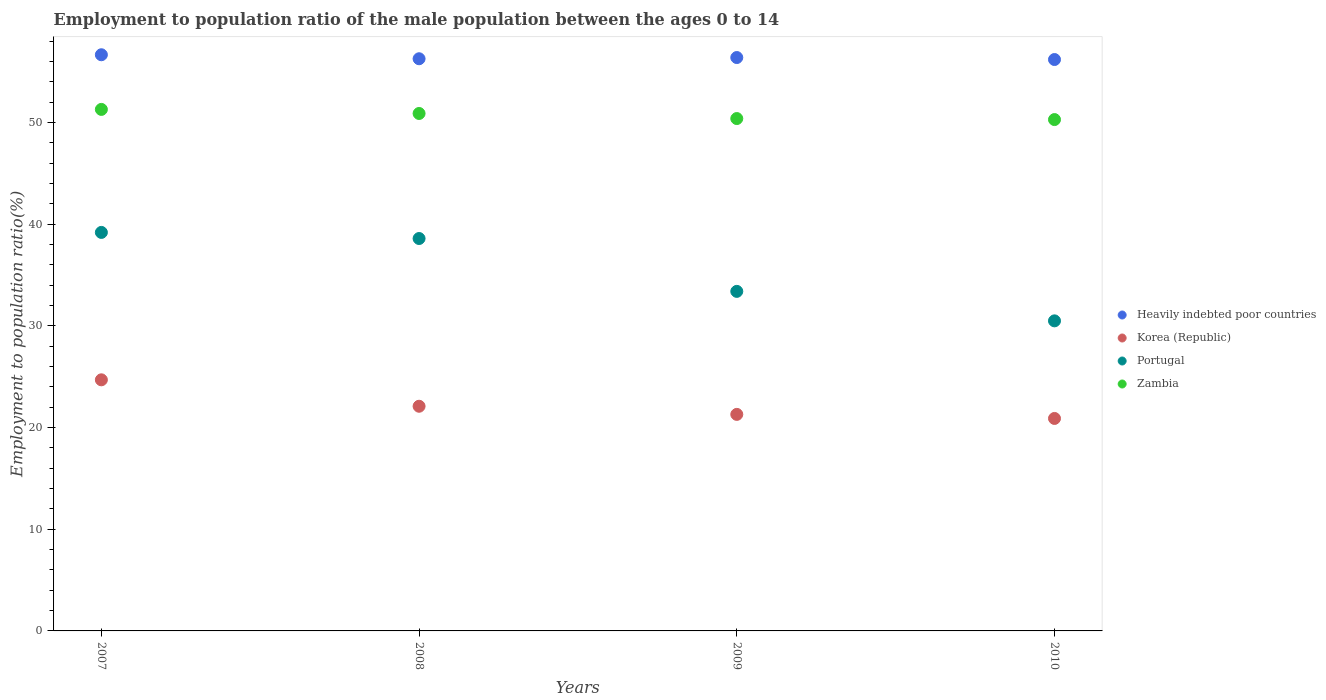What is the employment to population ratio in Korea (Republic) in 2010?
Offer a terse response. 20.9. Across all years, what is the maximum employment to population ratio in Portugal?
Keep it short and to the point. 39.2. Across all years, what is the minimum employment to population ratio in Korea (Republic)?
Your answer should be compact. 20.9. In which year was the employment to population ratio in Heavily indebted poor countries maximum?
Give a very brief answer. 2007. What is the total employment to population ratio in Korea (Republic) in the graph?
Keep it short and to the point. 89. What is the difference between the employment to population ratio in Zambia in 2007 and that in 2009?
Give a very brief answer. 0.9. What is the difference between the employment to population ratio in Korea (Republic) in 2008 and the employment to population ratio in Portugal in 2009?
Offer a terse response. -11.3. What is the average employment to population ratio in Korea (Republic) per year?
Keep it short and to the point. 22.25. In the year 2010, what is the difference between the employment to population ratio in Heavily indebted poor countries and employment to population ratio in Korea (Republic)?
Your answer should be very brief. 35.31. In how many years, is the employment to population ratio in Zambia greater than 8 %?
Give a very brief answer. 4. What is the ratio of the employment to population ratio in Zambia in 2007 to that in 2008?
Your answer should be compact. 1.01. Is the difference between the employment to population ratio in Heavily indebted poor countries in 2007 and 2010 greater than the difference between the employment to population ratio in Korea (Republic) in 2007 and 2010?
Your response must be concise. No. What is the difference between the highest and the second highest employment to population ratio in Heavily indebted poor countries?
Your response must be concise. 0.27. What is the difference between the highest and the lowest employment to population ratio in Portugal?
Make the answer very short. 8.7. In how many years, is the employment to population ratio in Korea (Republic) greater than the average employment to population ratio in Korea (Republic) taken over all years?
Your answer should be very brief. 1. Is the sum of the employment to population ratio in Zambia in 2007 and 2008 greater than the maximum employment to population ratio in Portugal across all years?
Provide a short and direct response. Yes. Is it the case that in every year, the sum of the employment to population ratio in Heavily indebted poor countries and employment to population ratio in Zambia  is greater than the sum of employment to population ratio in Portugal and employment to population ratio in Korea (Republic)?
Ensure brevity in your answer.  Yes. Does the employment to population ratio in Korea (Republic) monotonically increase over the years?
Your response must be concise. No. Is the employment to population ratio in Heavily indebted poor countries strictly less than the employment to population ratio in Portugal over the years?
Keep it short and to the point. No. How many dotlines are there?
Your answer should be very brief. 4. What is the difference between two consecutive major ticks on the Y-axis?
Give a very brief answer. 10. Are the values on the major ticks of Y-axis written in scientific E-notation?
Your answer should be very brief. No. Does the graph contain any zero values?
Your answer should be very brief. No. Does the graph contain grids?
Your answer should be very brief. No. Where does the legend appear in the graph?
Offer a terse response. Center right. How many legend labels are there?
Make the answer very short. 4. How are the legend labels stacked?
Provide a succinct answer. Vertical. What is the title of the graph?
Your response must be concise. Employment to population ratio of the male population between the ages 0 to 14. Does "St. Vincent and the Grenadines" appear as one of the legend labels in the graph?
Make the answer very short. No. What is the label or title of the X-axis?
Your answer should be compact. Years. What is the Employment to population ratio(%) of Heavily indebted poor countries in 2007?
Your response must be concise. 56.68. What is the Employment to population ratio(%) in Korea (Republic) in 2007?
Ensure brevity in your answer.  24.7. What is the Employment to population ratio(%) in Portugal in 2007?
Keep it short and to the point. 39.2. What is the Employment to population ratio(%) of Zambia in 2007?
Your response must be concise. 51.3. What is the Employment to population ratio(%) of Heavily indebted poor countries in 2008?
Give a very brief answer. 56.28. What is the Employment to population ratio(%) in Korea (Republic) in 2008?
Keep it short and to the point. 22.1. What is the Employment to population ratio(%) in Portugal in 2008?
Ensure brevity in your answer.  38.6. What is the Employment to population ratio(%) of Zambia in 2008?
Ensure brevity in your answer.  50.9. What is the Employment to population ratio(%) of Heavily indebted poor countries in 2009?
Keep it short and to the point. 56.4. What is the Employment to population ratio(%) of Korea (Republic) in 2009?
Provide a succinct answer. 21.3. What is the Employment to population ratio(%) of Portugal in 2009?
Your response must be concise. 33.4. What is the Employment to population ratio(%) of Zambia in 2009?
Provide a succinct answer. 50.4. What is the Employment to population ratio(%) of Heavily indebted poor countries in 2010?
Provide a succinct answer. 56.21. What is the Employment to population ratio(%) in Korea (Republic) in 2010?
Offer a terse response. 20.9. What is the Employment to population ratio(%) in Portugal in 2010?
Provide a short and direct response. 30.5. What is the Employment to population ratio(%) of Zambia in 2010?
Ensure brevity in your answer.  50.3. Across all years, what is the maximum Employment to population ratio(%) in Heavily indebted poor countries?
Keep it short and to the point. 56.68. Across all years, what is the maximum Employment to population ratio(%) in Korea (Republic)?
Provide a short and direct response. 24.7. Across all years, what is the maximum Employment to population ratio(%) of Portugal?
Your answer should be compact. 39.2. Across all years, what is the maximum Employment to population ratio(%) of Zambia?
Your response must be concise. 51.3. Across all years, what is the minimum Employment to population ratio(%) of Heavily indebted poor countries?
Offer a terse response. 56.21. Across all years, what is the minimum Employment to population ratio(%) in Korea (Republic)?
Keep it short and to the point. 20.9. Across all years, what is the minimum Employment to population ratio(%) of Portugal?
Provide a succinct answer. 30.5. Across all years, what is the minimum Employment to population ratio(%) in Zambia?
Offer a very short reply. 50.3. What is the total Employment to population ratio(%) in Heavily indebted poor countries in the graph?
Keep it short and to the point. 225.57. What is the total Employment to population ratio(%) in Korea (Republic) in the graph?
Your answer should be compact. 89. What is the total Employment to population ratio(%) in Portugal in the graph?
Provide a succinct answer. 141.7. What is the total Employment to population ratio(%) of Zambia in the graph?
Offer a very short reply. 202.9. What is the difference between the Employment to population ratio(%) of Heavily indebted poor countries in 2007 and that in 2008?
Provide a short and direct response. 0.39. What is the difference between the Employment to population ratio(%) of Korea (Republic) in 2007 and that in 2008?
Your answer should be compact. 2.6. What is the difference between the Employment to population ratio(%) of Portugal in 2007 and that in 2008?
Offer a terse response. 0.6. What is the difference between the Employment to population ratio(%) in Heavily indebted poor countries in 2007 and that in 2009?
Offer a very short reply. 0.27. What is the difference between the Employment to population ratio(%) in Korea (Republic) in 2007 and that in 2009?
Make the answer very short. 3.4. What is the difference between the Employment to population ratio(%) of Portugal in 2007 and that in 2009?
Your answer should be very brief. 5.8. What is the difference between the Employment to population ratio(%) in Heavily indebted poor countries in 2007 and that in 2010?
Keep it short and to the point. 0.47. What is the difference between the Employment to population ratio(%) in Zambia in 2007 and that in 2010?
Your answer should be compact. 1. What is the difference between the Employment to population ratio(%) of Heavily indebted poor countries in 2008 and that in 2009?
Ensure brevity in your answer.  -0.12. What is the difference between the Employment to population ratio(%) in Korea (Republic) in 2008 and that in 2009?
Offer a very short reply. 0.8. What is the difference between the Employment to population ratio(%) of Portugal in 2008 and that in 2009?
Offer a very short reply. 5.2. What is the difference between the Employment to population ratio(%) of Heavily indebted poor countries in 2008 and that in 2010?
Offer a terse response. 0.08. What is the difference between the Employment to population ratio(%) in Portugal in 2008 and that in 2010?
Ensure brevity in your answer.  8.1. What is the difference between the Employment to population ratio(%) of Zambia in 2008 and that in 2010?
Keep it short and to the point. 0.6. What is the difference between the Employment to population ratio(%) of Heavily indebted poor countries in 2009 and that in 2010?
Give a very brief answer. 0.2. What is the difference between the Employment to population ratio(%) of Heavily indebted poor countries in 2007 and the Employment to population ratio(%) of Korea (Republic) in 2008?
Your response must be concise. 34.58. What is the difference between the Employment to population ratio(%) of Heavily indebted poor countries in 2007 and the Employment to population ratio(%) of Portugal in 2008?
Keep it short and to the point. 18.08. What is the difference between the Employment to population ratio(%) of Heavily indebted poor countries in 2007 and the Employment to population ratio(%) of Zambia in 2008?
Ensure brevity in your answer.  5.78. What is the difference between the Employment to population ratio(%) in Korea (Republic) in 2007 and the Employment to population ratio(%) in Portugal in 2008?
Ensure brevity in your answer.  -13.9. What is the difference between the Employment to population ratio(%) of Korea (Republic) in 2007 and the Employment to population ratio(%) of Zambia in 2008?
Your response must be concise. -26.2. What is the difference between the Employment to population ratio(%) of Heavily indebted poor countries in 2007 and the Employment to population ratio(%) of Korea (Republic) in 2009?
Ensure brevity in your answer.  35.38. What is the difference between the Employment to population ratio(%) in Heavily indebted poor countries in 2007 and the Employment to population ratio(%) in Portugal in 2009?
Provide a short and direct response. 23.28. What is the difference between the Employment to population ratio(%) in Heavily indebted poor countries in 2007 and the Employment to population ratio(%) in Zambia in 2009?
Make the answer very short. 6.28. What is the difference between the Employment to population ratio(%) of Korea (Republic) in 2007 and the Employment to population ratio(%) of Zambia in 2009?
Provide a short and direct response. -25.7. What is the difference between the Employment to population ratio(%) of Portugal in 2007 and the Employment to population ratio(%) of Zambia in 2009?
Make the answer very short. -11.2. What is the difference between the Employment to population ratio(%) of Heavily indebted poor countries in 2007 and the Employment to population ratio(%) of Korea (Republic) in 2010?
Your answer should be compact. 35.78. What is the difference between the Employment to population ratio(%) in Heavily indebted poor countries in 2007 and the Employment to population ratio(%) in Portugal in 2010?
Provide a succinct answer. 26.18. What is the difference between the Employment to population ratio(%) of Heavily indebted poor countries in 2007 and the Employment to population ratio(%) of Zambia in 2010?
Offer a very short reply. 6.38. What is the difference between the Employment to population ratio(%) in Korea (Republic) in 2007 and the Employment to population ratio(%) in Zambia in 2010?
Your response must be concise. -25.6. What is the difference between the Employment to population ratio(%) of Portugal in 2007 and the Employment to population ratio(%) of Zambia in 2010?
Provide a succinct answer. -11.1. What is the difference between the Employment to population ratio(%) of Heavily indebted poor countries in 2008 and the Employment to population ratio(%) of Korea (Republic) in 2009?
Your answer should be compact. 34.98. What is the difference between the Employment to population ratio(%) of Heavily indebted poor countries in 2008 and the Employment to population ratio(%) of Portugal in 2009?
Your answer should be very brief. 22.88. What is the difference between the Employment to population ratio(%) in Heavily indebted poor countries in 2008 and the Employment to population ratio(%) in Zambia in 2009?
Provide a succinct answer. 5.88. What is the difference between the Employment to population ratio(%) in Korea (Republic) in 2008 and the Employment to population ratio(%) in Zambia in 2009?
Keep it short and to the point. -28.3. What is the difference between the Employment to population ratio(%) in Portugal in 2008 and the Employment to population ratio(%) in Zambia in 2009?
Your response must be concise. -11.8. What is the difference between the Employment to population ratio(%) in Heavily indebted poor countries in 2008 and the Employment to population ratio(%) in Korea (Republic) in 2010?
Provide a succinct answer. 35.38. What is the difference between the Employment to population ratio(%) of Heavily indebted poor countries in 2008 and the Employment to population ratio(%) of Portugal in 2010?
Make the answer very short. 25.78. What is the difference between the Employment to population ratio(%) of Heavily indebted poor countries in 2008 and the Employment to population ratio(%) of Zambia in 2010?
Offer a terse response. 5.98. What is the difference between the Employment to population ratio(%) of Korea (Republic) in 2008 and the Employment to population ratio(%) of Portugal in 2010?
Your answer should be compact. -8.4. What is the difference between the Employment to population ratio(%) in Korea (Republic) in 2008 and the Employment to population ratio(%) in Zambia in 2010?
Offer a terse response. -28.2. What is the difference between the Employment to population ratio(%) of Heavily indebted poor countries in 2009 and the Employment to population ratio(%) of Korea (Republic) in 2010?
Your answer should be very brief. 35.5. What is the difference between the Employment to population ratio(%) of Heavily indebted poor countries in 2009 and the Employment to population ratio(%) of Portugal in 2010?
Keep it short and to the point. 25.9. What is the difference between the Employment to population ratio(%) in Heavily indebted poor countries in 2009 and the Employment to population ratio(%) in Zambia in 2010?
Provide a short and direct response. 6.1. What is the difference between the Employment to population ratio(%) in Korea (Republic) in 2009 and the Employment to population ratio(%) in Portugal in 2010?
Give a very brief answer. -9.2. What is the difference between the Employment to population ratio(%) in Portugal in 2009 and the Employment to population ratio(%) in Zambia in 2010?
Offer a very short reply. -16.9. What is the average Employment to population ratio(%) of Heavily indebted poor countries per year?
Your response must be concise. 56.39. What is the average Employment to population ratio(%) in Korea (Republic) per year?
Your answer should be very brief. 22.25. What is the average Employment to population ratio(%) of Portugal per year?
Your response must be concise. 35.42. What is the average Employment to population ratio(%) of Zambia per year?
Keep it short and to the point. 50.73. In the year 2007, what is the difference between the Employment to population ratio(%) in Heavily indebted poor countries and Employment to population ratio(%) in Korea (Republic)?
Offer a terse response. 31.98. In the year 2007, what is the difference between the Employment to population ratio(%) in Heavily indebted poor countries and Employment to population ratio(%) in Portugal?
Give a very brief answer. 17.48. In the year 2007, what is the difference between the Employment to population ratio(%) in Heavily indebted poor countries and Employment to population ratio(%) in Zambia?
Give a very brief answer. 5.38. In the year 2007, what is the difference between the Employment to population ratio(%) of Korea (Republic) and Employment to population ratio(%) of Portugal?
Provide a short and direct response. -14.5. In the year 2007, what is the difference between the Employment to population ratio(%) in Korea (Republic) and Employment to population ratio(%) in Zambia?
Your answer should be very brief. -26.6. In the year 2008, what is the difference between the Employment to population ratio(%) in Heavily indebted poor countries and Employment to population ratio(%) in Korea (Republic)?
Keep it short and to the point. 34.18. In the year 2008, what is the difference between the Employment to population ratio(%) of Heavily indebted poor countries and Employment to population ratio(%) of Portugal?
Provide a succinct answer. 17.68. In the year 2008, what is the difference between the Employment to population ratio(%) of Heavily indebted poor countries and Employment to population ratio(%) of Zambia?
Provide a short and direct response. 5.38. In the year 2008, what is the difference between the Employment to population ratio(%) of Korea (Republic) and Employment to population ratio(%) of Portugal?
Your answer should be compact. -16.5. In the year 2008, what is the difference between the Employment to population ratio(%) of Korea (Republic) and Employment to population ratio(%) of Zambia?
Give a very brief answer. -28.8. In the year 2009, what is the difference between the Employment to population ratio(%) of Heavily indebted poor countries and Employment to population ratio(%) of Korea (Republic)?
Provide a succinct answer. 35.1. In the year 2009, what is the difference between the Employment to population ratio(%) of Heavily indebted poor countries and Employment to population ratio(%) of Portugal?
Offer a very short reply. 23. In the year 2009, what is the difference between the Employment to population ratio(%) in Heavily indebted poor countries and Employment to population ratio(%) in Zambia?
Ensure brevity in your answer.  6. In the year 2009, what is the difference between the Employment to population ratio(%) in Korea (Republic) and Employment to population ratio(%) in Portugal?
Make the answer very short. -12.1. In the year 2009, what is the difference between the Employment to population ratio(%) of Korea (Republic) and Employment to population ratio(%) of Zambia?
Offer a terse response. -29.1. In the year 2010, what is the difference between the Employment to population ratio(%) in Heavily indebted poor countries and Employment to population ratio(%) in Korea (Republic)?
Your answer should be compact. 35.31. In the year 2010, what is the difference between the Employment to population ratio(%) in Heavily indebted poor countries and Employment to population ratio(%) in Portugal?
Keep it short and to the point. 25.71. In the year 2010, what is the difference between the Employment to population ratio(%) of Heavily indebted poor countries and Employment to population ratio(%) of Zambia?
Make the answer very short. 5.91. In the year 2010, what is the difference between the Employment to population ratio(%) of Korea (Republic) and Employment to population ratio(%) of Zambia?
Make the answer very short. -29.4. In the year 2010, what is the difference between the Employment to population ratio(%) in Portugal and Employment to population ratio(%) in Zambia?
Your answer should be compact. -19.8. What is the ratio of the Employment to population ratio(%) in Korea (Republic) in 2007 to that in 2008?
Keep it short and to the point. 1.12. What is the ratio of the Employment to population ratio(%) of Portugal in 2007 to that in 2008?
Provide a succinct answer. 1.02. What is the ratio of the Employment to population ratio(%) of Zambia in 2007 to that in 2008?
Your answer should be very brief. 1.01. What is the ratio of the Employment to population ratio(%) of Korea (Republic) in 2007 to that in 2009?
Your response must be concise. 1.16. What is the ratio of the Employment to population ratio(%) in Portugal in 2007 to that in 2009?
Provide a short and direct response. 1.17. What is the ratio of the Employment to population ratio(%) of Zambia in 2007 to that in 2009?
Provide a succinct answer. 1.02. What is the ratio of the Employment to population ratio(%) of Heavily indebted poor countries in 2007 to that in 2010?
Give a very brief answer. 1.01. What is the ratio of the Employment to population ratio(%) of Korea (Republic) in 2007 to that in 2010?
Your answer should be very brief. 1.18. What is the ratio of the Employment to population ratio(%) in Portugal in 2007 to that in 2010?
Provide a short and direct response. 1.29. What is the ratio of the Employment to population ratio(%) in Zambia in 2007 to that in 2010?
Offer a very short reply. 1.02. What is the ratio of the Employment to population ratio(%) in Korea (Republic) in 2008 to that in 2009?
Ensure brevity in your answer.  1.04. What is the ratio of the Employment to population ratio(%) in Portugal in 2008 to that in 2009?
Keep it short and to the point. 1.16. What is the ratio of the Employment to population ratio(%) in Zambia in 2008 to that in 2009?
Offer a very short reply. 1.01. What is the ratio of the Employment to population ratio(%) of Heavily indebted poor countries in 2008 to that in 2010?
Offer a terse response. 1. What is the ratio of the Employment to population ratio(%) in Korea (Republic) in 2008 to that in 2010?
Ensure brevity in your answer.  1.06. What is the ratio of the Employment to population ratio(%) of Portugal in 2008 to that in 2010?
Your answer should be very brief. 1.27. What is the ratio of the Employment to population ratio(%) in Zambia in 2008 to that in 2010?
Provide a short and direct response. 1.01. What is the ratio of the Employment to population ratio(%) of Korea (Republic) in 2009 to that in 2010?
Provide a short and direct response. 1.02. What is the ratio of the Employment to population ratio(%) in Portugal in 2009 to that in 2010?
Your answer should be compact. 1.1. What is the difference between the highest and the second highest Employment to population ratio(%) in Heavily indebted poor countries?
Give a very brief answer. 0.27. What is the difference between the highest and the second highest Employment to population ratio(%) in Korea (Republic)?
Make the answer very short. 2.6. What is the difference between the highest and the lowest Employment to population ratio(%) in Heavily indebted poor countries?
Ensure brevity in your answer.  0.47. What is the difference between the highest and the lowest Employment to population ratio(%) in Korea (Republic)?
Provide a succinct answer. 3.8. What is the difference between the highest and the lowest Employment to population ratio(%) of Zambia?
Your answer should be very brief. 1. 